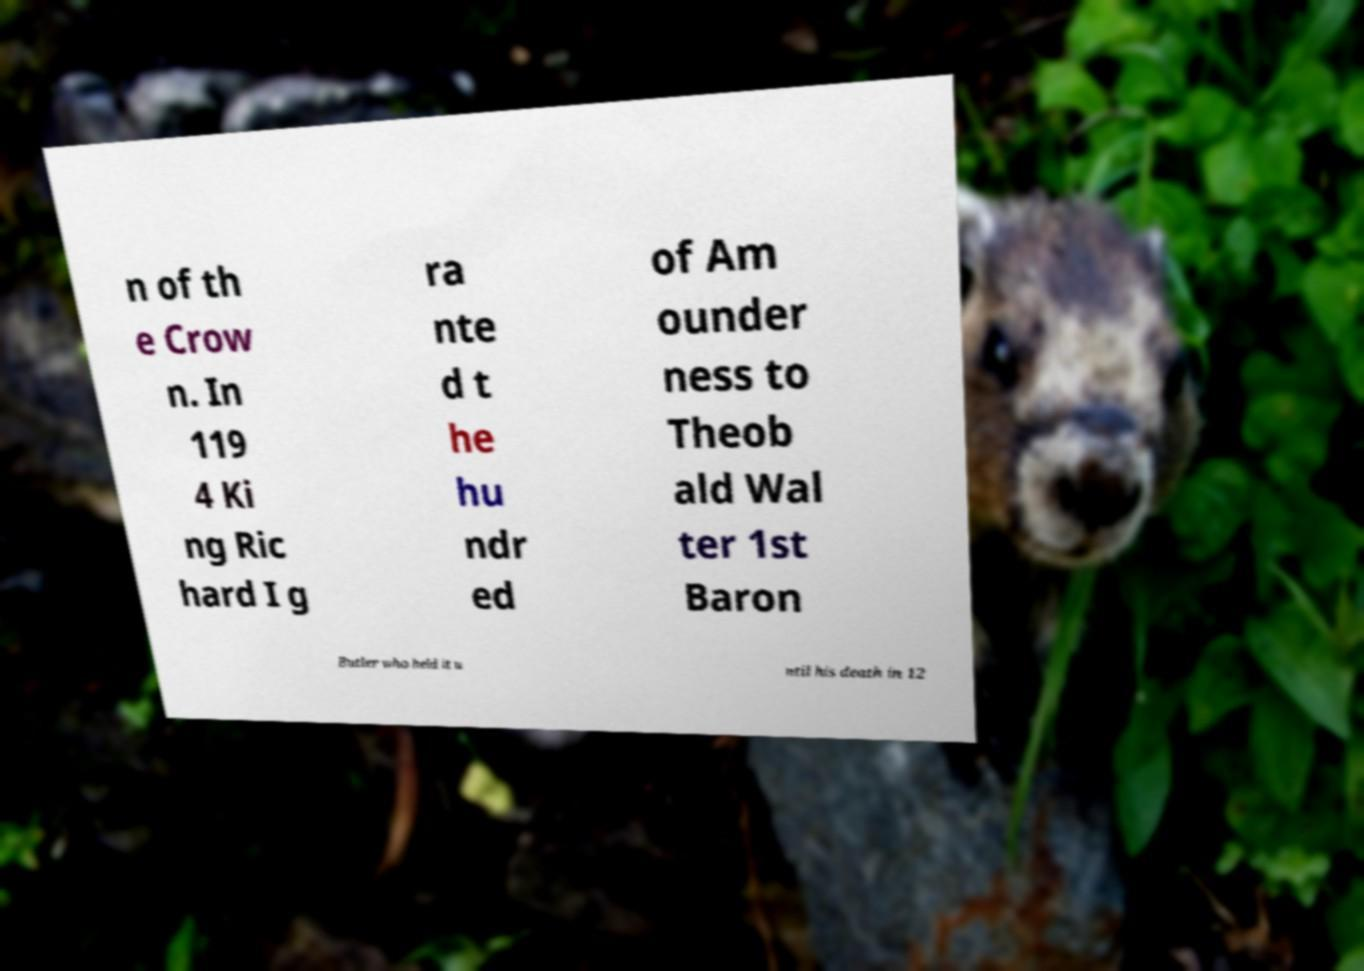What messages or text are displayed in this image? I need them in a readable, typed format. n of th e Crow n. In 119 4 Ki ng Ric hard I g ra nte d t he hu ndr ed of Am ounder ness to Theob ald Wal ter 1st Baron Butler who held it u ntil his death in 12 